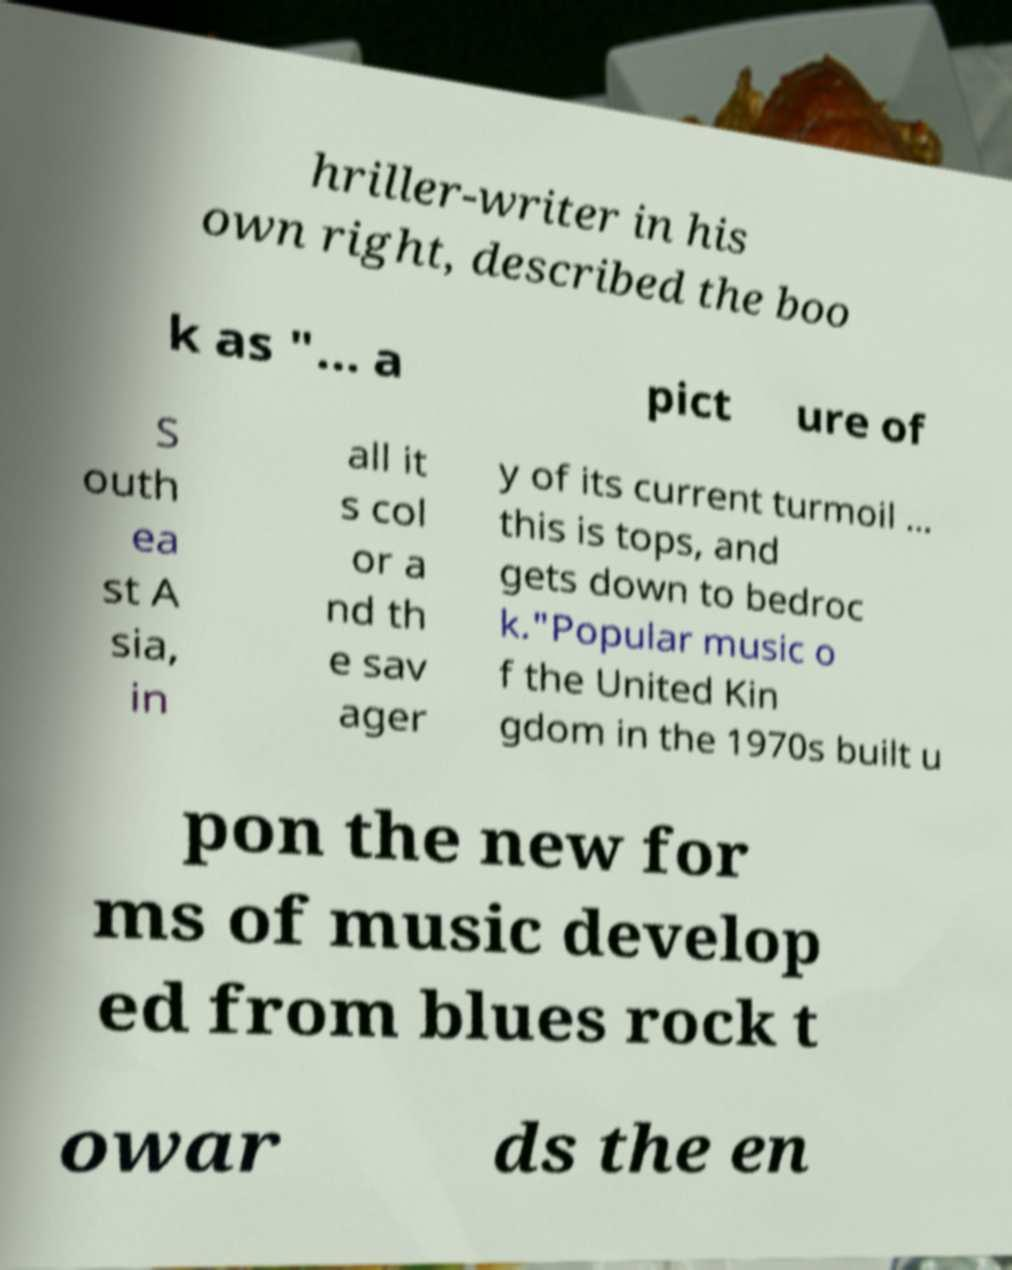Please identify and transcribe the text found in this image. hriller-writer in his own right, described the boo k as "... a pict ure of S outh ea st A sia, in all it s col or a nd th e sav ager y of its current turmoil ... this is tops, and gets down to bedroc k."Popular music o f the United Kin gdom in the 1970s built u pon the new for ms of music develop ed from blues rock t owar ds the en 